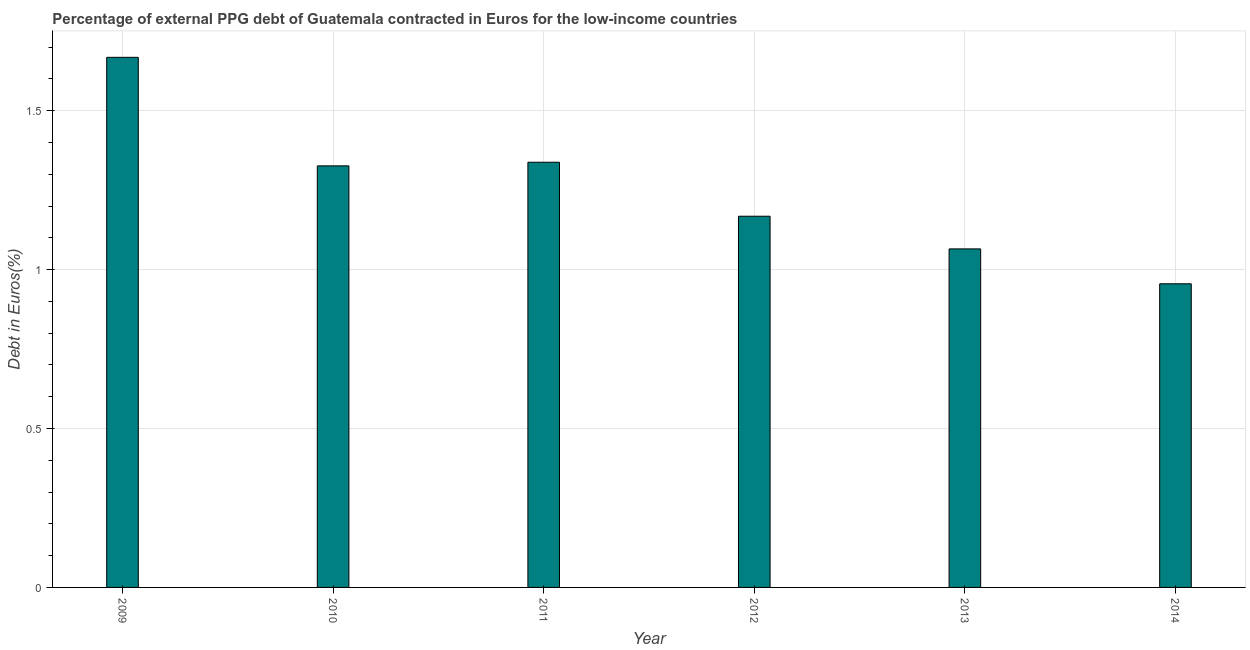What is the title of the graph?
Keep it short and to the point. Percentage of external PPG debt of Guatemala contracted in Euros for the low-income countries. What is the label or title of the X-axis?
Make the answer very short. Year. What is the label or title of the Y-axis?
Your answer should be very brief. Debt in Euros(%). What is the currency composition of ppg debt in 2012?
Give a very brief answer. 1.17. Across all years, what is the maximum currency composition of ppg debt?
Offer a very short reply. 1.67. Across all years, what is the minimum currency composition of ppg debt?
Provide a short and direct response. 0.96. What is the sum of the currency composition of ppg debt?
Make the answer very short. 7.52. What is the difference between the currency composition of ppg debt in 2013 and 2014?
Give a very brief answer. 0.11. What is the average currency composition of ppg debt per year?
Provide a short and direct response. 1.25. What is the median currency composition of ppg debt?
Your response must be concise. 1.25. Do a majority of the years between 2010 and 2013 (inclusive) have currency composition of ppg debt greater than 0.2 %?
Provide a succinct answer. Yes. What is the ratio of the currency composition of ppg debt in 2009 to that in 2014?
Make the answer very short. 1.75. Is the currency composition of ppg debt in 2010 less than that in 2012?
Ensure brevity in your answer.  No. What is the difference between the highest and the second highest currency composition of ppg debt?
Give a very brief answer. 0.33. Is the sum of the currency composition of ppg debt in 2010 and 2013 greater than the maximum currency composition of ppg debt across all years?
Offer a terse response. Yes. What is the difference between the highest and the lowest currency composition of ppg debt?
Give a very brief answer. 0.71. In how many years, is the currency composition of ppg debt greater than the average currency composition of ppg debt taken over all years?
Ensure brevity in your answer.  3. Are all the bars in the graph horizontal?
Your answer should be very brief. No. What is the difference between two consecutive major ticks on the Y-axis?
Make the answer very short. 0.5. Are the values on the major ticks of Y-axis written in scientific E-notation?
Provide a short and direct response. No. What is the Debt in Euros(%) of 2009?
Your answer should be compact. 1.67. What is the Debt in Euros(%) in 2010?
Your response must be concise. 1.33. What is the Debt in Euros(%) in 2011?
Give a very brief answer. 1.34. What is the Debt in Euros(%) in 2012?
Provide a short and direct response. 1.17. What is the Debt in Euros(%) of 2013?
Your answer should be compact. 1.07. What is the Debt in Euros(%) of 2014?
Keep it short and to the point. 0.96. What is the difference between the Debt in Euros(%) in 2009 and 2010?
Give a very brief answer. 0.34. What is the difference between the Debt in Euros(%) in 2009 and 2011?
Your response must be concise. 0.33. What is the difference between the Debt in Euros(%) in 2009 and 2012?
Make the answer very short. 0.5. What is the difference between the Debt in Euros(%) in 2009 and 2013?
Provide a short and direct response. 0.6. What is the difference between the Debt in Euros(%) in 2009 and 2014?
Make the answer very short. 0.71. What is the difference between the Debt in Euros(%) in 2010 and 2011?
Provide a short and direct response. -0.01. What is the difference between the Debt in Euros(%) in 2010 and 2012?
Ensure brevity in your answer.  0.16. What is the difference between the Debt in Euros(%) in 2010 and 2013?
Make the answer very short. 0.26. What is the difference between the Debt in Euros(%) in 2010 and 2014?
Make the answer very short. 0.37. What is the difference between the Debt in Euros(%) in 2011 and 2012?
Offer a very short reply. 0.17. What is the difference between the Debt in Euros(%) in 2011 and 2013?
Ensure brevity in your answer.  0.27. What is the difference between the Debt in Euros(%) in 2011 and 2014?
Keep it short and to the point. 0.38. What is the difference between the Debt in Euros(%) in 2012 and 2013?
Your answer should be very brief. 0.1. What is the difference between the Debt in Euros(%) in 2012 and 2014?
Ensure brevity in your answer.  0.21. What is the difference between the Debt in Euros(%) in 2013 and 2014?
Keep it short and to the point. 0.11. What is the ratio of the Debt in Euros(%) in 2009 to that in 2010?
Offer a very short reply. 1.26. What is the ratio of the Debt in Euros(%) in 2009 to that in 2011?
Ensure brevity in your answer.  1.25. What is the ratio of the Debt in Euros(%) in 2009 to that in 2012?
Make the answer very short. 1.43. What is the ratio of the Debt in Euros(%) in 2009 to that in 2013?
Keep it short and to the point. 1.57. What is the ratio of the Debt in Euros(%) in 2009 to that in 2014?
Offer a terse response. 1.75. What is the ratio of the Debt in Euros(%) in 2010 to that in 2012?
Offer a terse response. 1.14. What is the ratio of the Debt in Euros(%) in 2010 to that in 2013?
Give a very brief answer. 1.25. What is the ratio of the Debt in Euros(%) in 2010 to that in 2014?
Give a very brief answer. 1.39. What is the ratio of the Debt in Euros(%) in 2011 to that in 2012?
Provide a short and direct response. 1.15. What is the ratio of the Debt in Euros(%) in 2011 to that in 2013?
Ensure brevity in your answer.  1.26. What is the ratio of the Debt in Euros(%) in 2011 to that in 2014?
Make the answer very short. 1.4. What is the ratio of the Debt in Euros(%) in 2012 to that in 2013?
Ensure brevity in your answer.  1.1. What is the ratio of the Debt in Euros(%) in 2012 to that in 2014?
Your response must be concise. 1.22. What is the ratio of the Debt in Euros(%) in 2013 to that in 2014?
Provide a short and direct response. 1.11. 